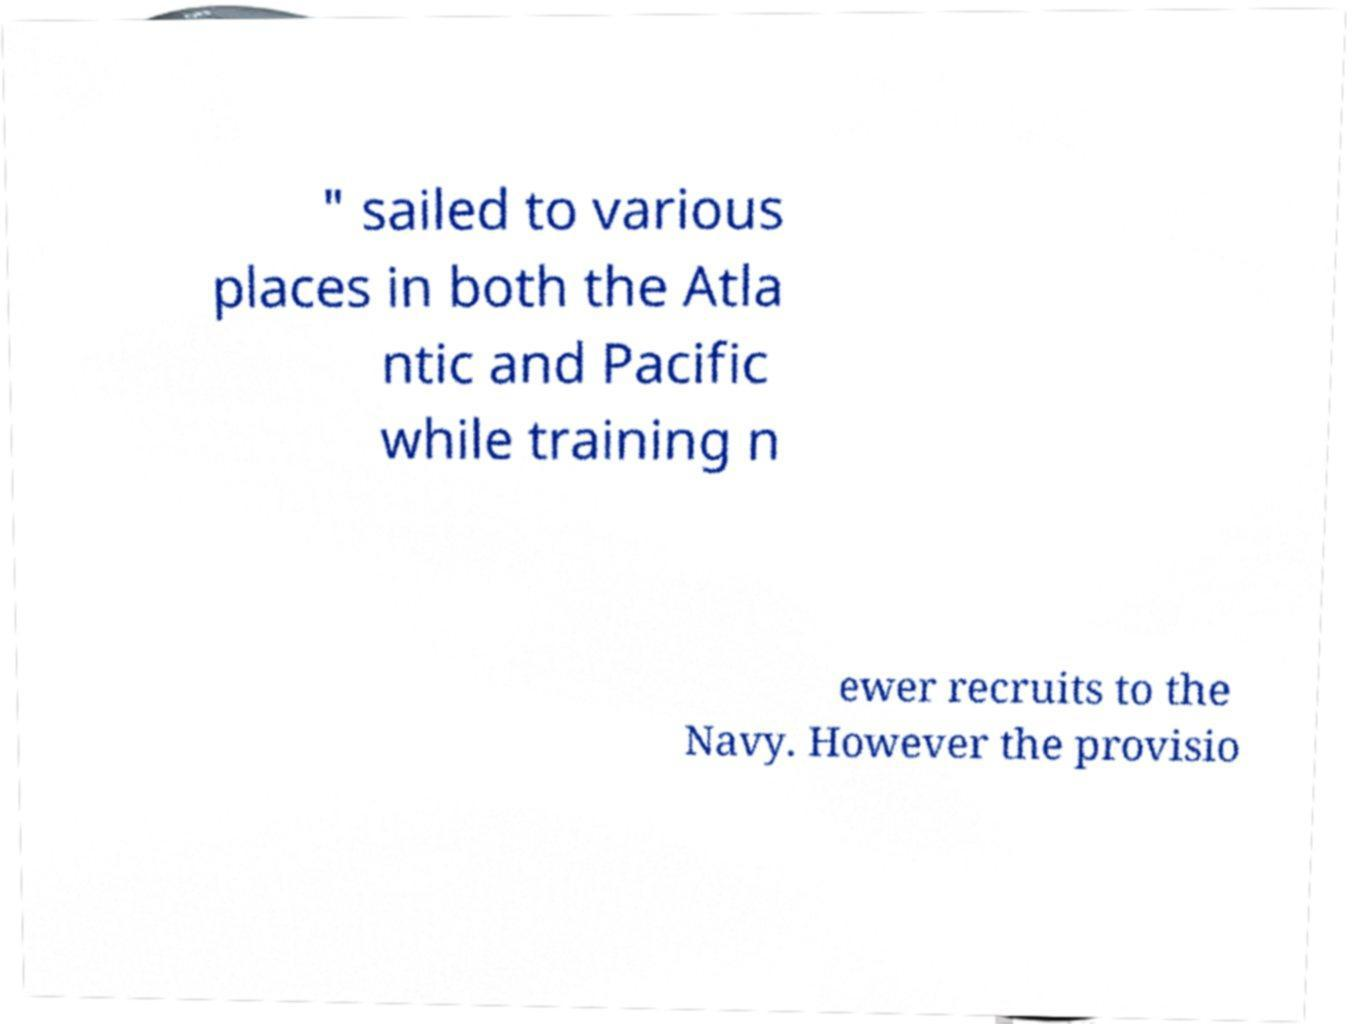Can you accurately transcribe the text from the provided image for me? " sailed to various places in both the Atla ntic and Pacific while training n ewer recruits to the Navy. However the provisio 